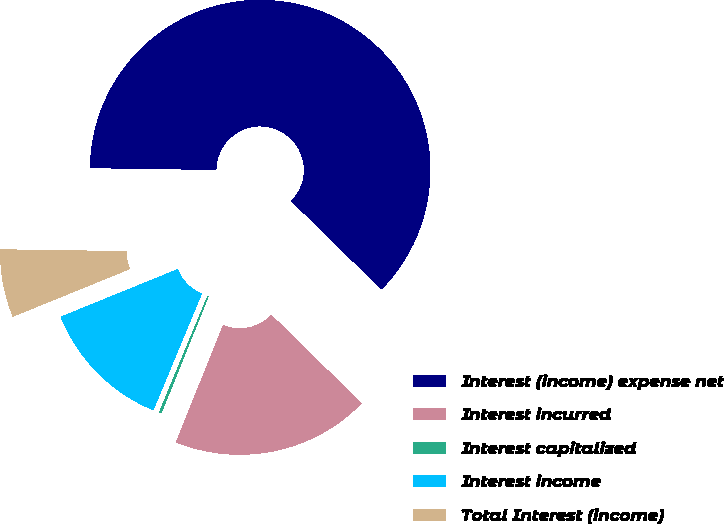<chart> <loc_0><loc_0><loc_500><loc_500><pie_chart><fcel>Interest (income) expense net<fcel>Interest incurred<fcel>Interest capitalized<fcel>Interest income<fcel>Total Interest (income)<nl><fcel>62.11%<fcel>18.76%<fcel>0.18%<fcel>12.57%<fcel>6.38%<nl></chart> 